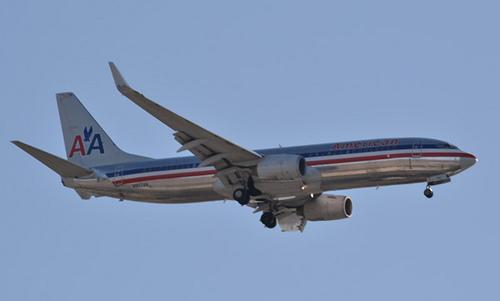In the context of visual entailment, what can be deduced about the airplane's altitude? Given the clear blue sky in the background, we can deduce that the airplane is at a considerable altitude. Which part of the airplane has the letterings "aa" painted? The "aa" letterings are painted on the tail of the plane. Describe the design and features of the plane's tail section. The tail section is white with a blue letter 'a' and a red letter 'a' on a gray background, wing on back-left near tail, and an AA logo. If this image is used to advertise a product, what could that product be? The product being advertised could be a commercial airplane, an airline company, or travel services. Provide a brief description of the plane's appearance and what it's doing. The plane is silver with red and blue stripes, American painted, and AA logo on the tail, flying through a clear blue sky with its wheels out. Locate and describe the feature near the cockpit that helps with visibility. A white light is present on the tip of the nose near the cockpit, which might aid in visibility during flight. Identify the primary object in the image and mention its color. The primary object is a silver plane flying in the clear blue sky. What can you infer about the plane's current activity? The plane is flying and in the air, with its wheels out and landing gear visible. Name three prominent colors present in the image and where they appear. Blue, found in the sky and on the plane's stripes; red, on the plane's stripes and lettering; and silver, on the plane's body and jets. What are some features that can be observed on the side of the plane? There is row of windows, red and white stripes, American painted and company name in red lettering. 